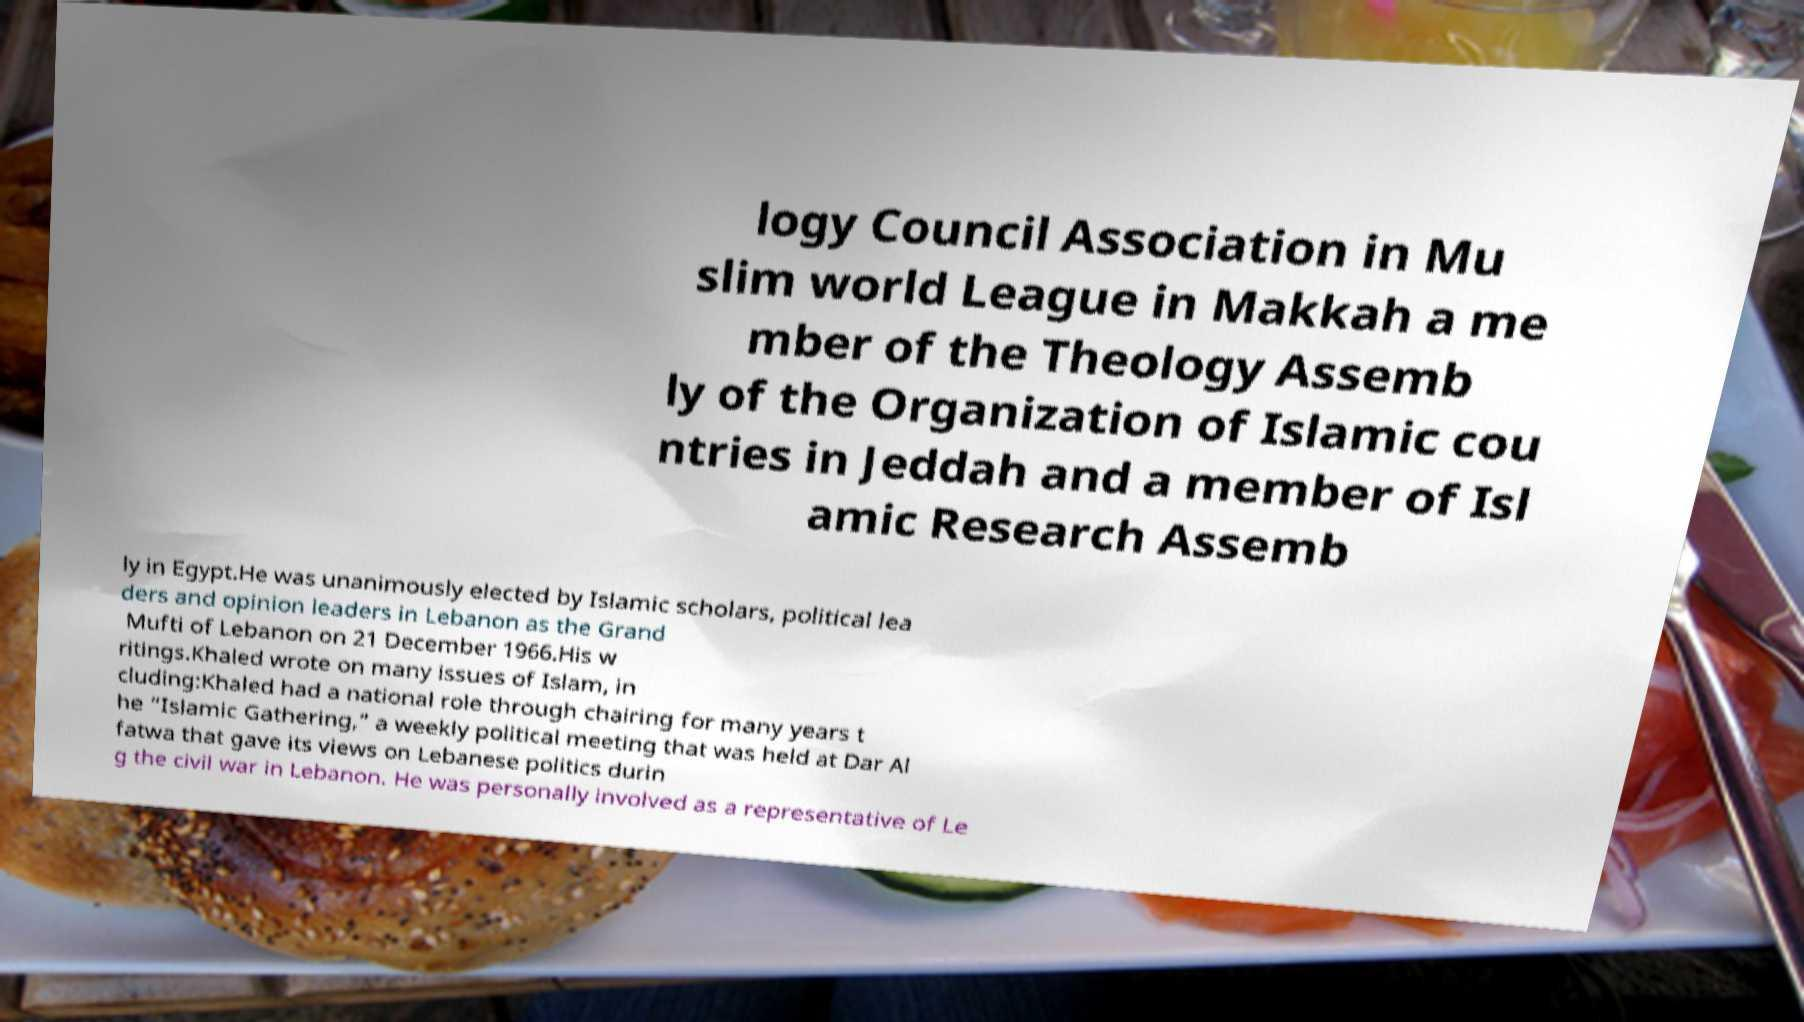For documentation purposes, I need the text within this image transcribed. Could you provide that? logy Council Association in Mu slim world League in Makkah a me mber of the Theology Assemb ly of the Organization of Islamic cou ntries in Jeddah and a member of Isl amic Research Assemb ly in Egypt.He was unanimously elected by Islamic scholars, political lea ders and opinion leaders in Lebanon as the Grand Mufti of Lebanon on 21 December 1966.His w ritings.Khaled wrote on many issues of Islam, in cluding:Khaled had a national role through chairing for many years t he “Islamic Gathering,” a weekly political meeting that was held at Dar Al fatwa that gave its views on Lebanese politics durin g the civil war in Lebanon. He was personally involved as a representative of Le 